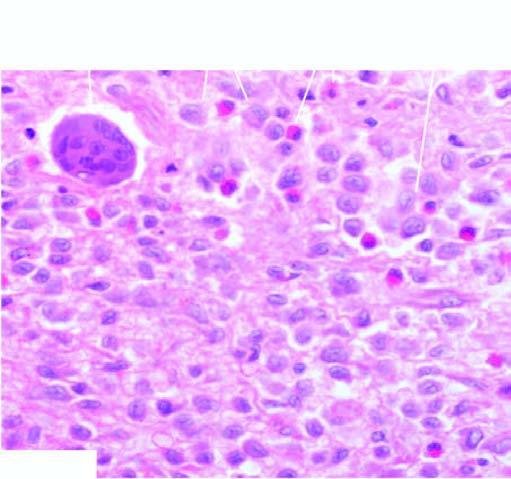what have vesicular nuclei admixed with eosinophils?
Answer the question using a single word or phrase. Presence of infiltrate by collections of histiocytes 